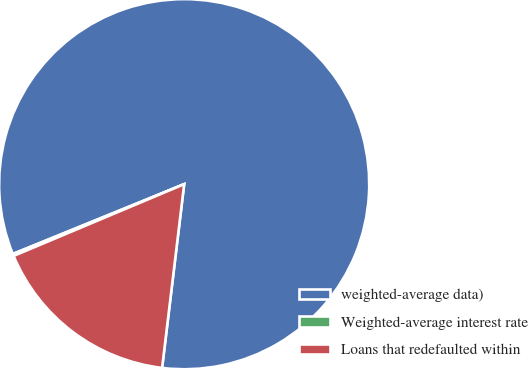Convert chart to OTSL. <chart><loc_0><loc_0><loc_500><loc_500><pie_chart><fcel>weighted-average data)<fcel>Weighted-average interest rate<fcel>Loans that redefaulted within<nl><fcel>83.06%<fcel>0.18%<fcel>16.76%<nl></chart> 